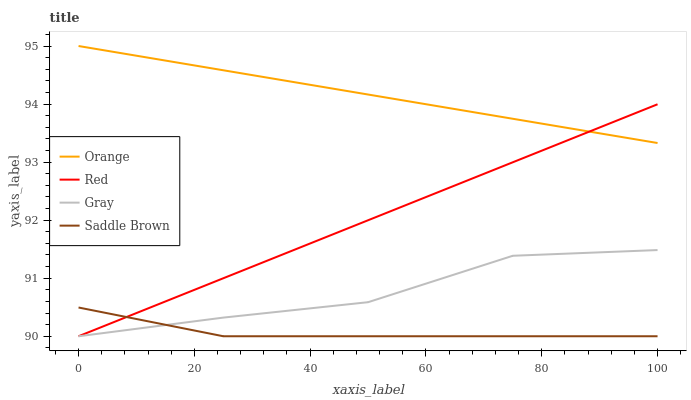Does Saddle Brown have the minimum area under the curve?
Answer yes or no. Yes. Does Orange have the maximum area under the curve?
Answer yes or no. Yes. Does Gray have the minimum area under the curve?
Answer yes or no. No. Does Gray have the maximum area under the curve?
Answer yes or no. No. Is Red the smoothest?
Answer yes or no. Yes. Is Gray the roughest?
Answer yes or no. Yes. Is Saddle Brown the smoothest?
Answer yes or no. No. Is Saddle Brown the roughest?
Answer yes or no. No. Does Gray have the lowest value?
Answer yes or no. Yes. Does Orange have the highest value?
Answer yes or no. Yes. Does Gray have the highest value?
Answer yes or no. No. Is Gray less than Orange?
Answer yes or no. Yes. Is Orange greater than Gray?
Answer yes or no. Yes. Does Saddle Brown intersect Red?
Answer yes or no. Yes. Is Saddle Brown less than Red?
Answer yes or no. No. Is Saddle Brown greater than Red?
Answer yes or no. No. Does Gray intersect Orange?
Answer yes or no. No. 